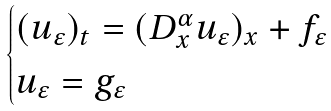Convert formula to latex. <formula><loc_0><loc_0><loc_500><loc_500>\begin{cases} ( u _ { \varepsilon } ) _ { t } = ( D _ { x } ^ { \alpha } u _ { \varepsilon } ) _ { x } + f _ { \varepsilon } \quad & \\ u _ { \varepsilon } = g _ { \varepsilon } \quad & \end{cases}</formula> 